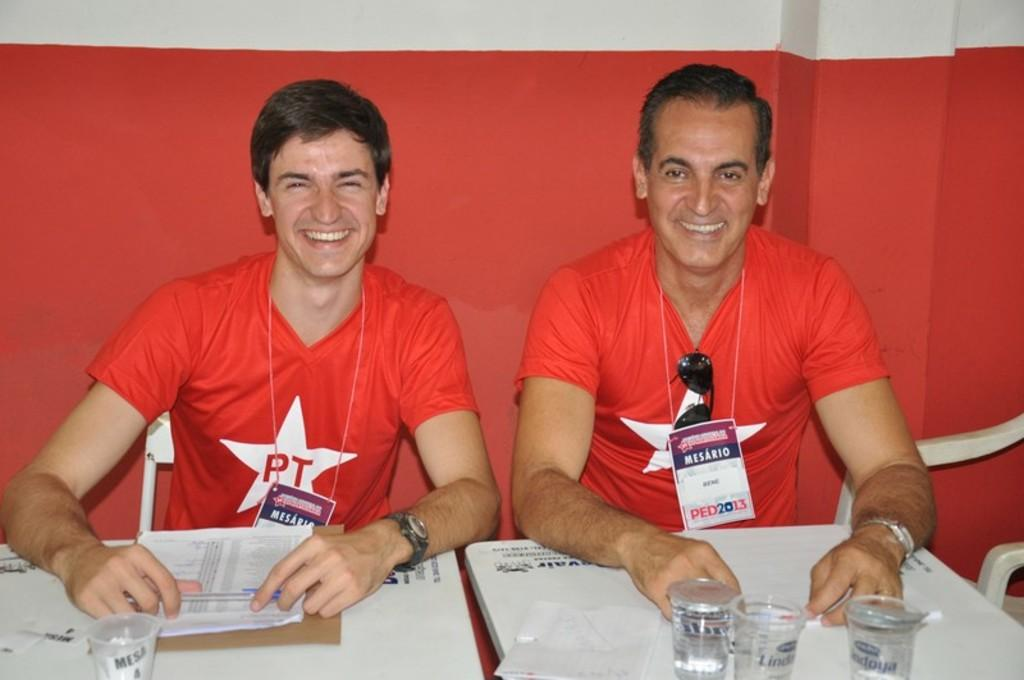<image>
Give a short and clear explanation of the subsequent image. Two men sitting at a table wearing red t-shirts with a PT logo. 